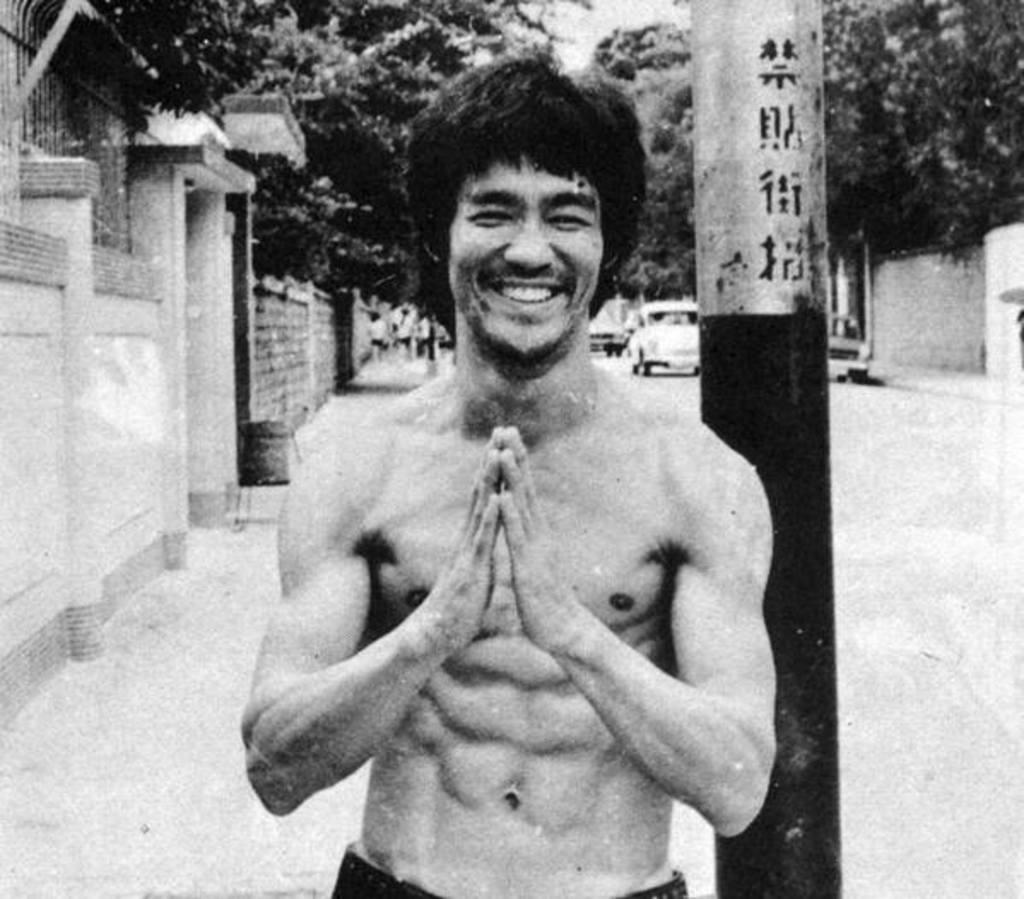What is the color scheme of the image? The image is black and white. Who or what is the main subject in the image? There is a person in the center of the image. What can be seen in the background of the image? There is a pole, trees, cars, a wall, and a road in the background of the image. Can you tell me how many tomatoes are on the person's head in the image? There are no tomatoes present in the image; it is a black and white image featuring a person in the center and various background elements. Is there an argument taking place between the person and the pole in the image? There is no indication of an argument or any interaction between the person and the pole in the image. 